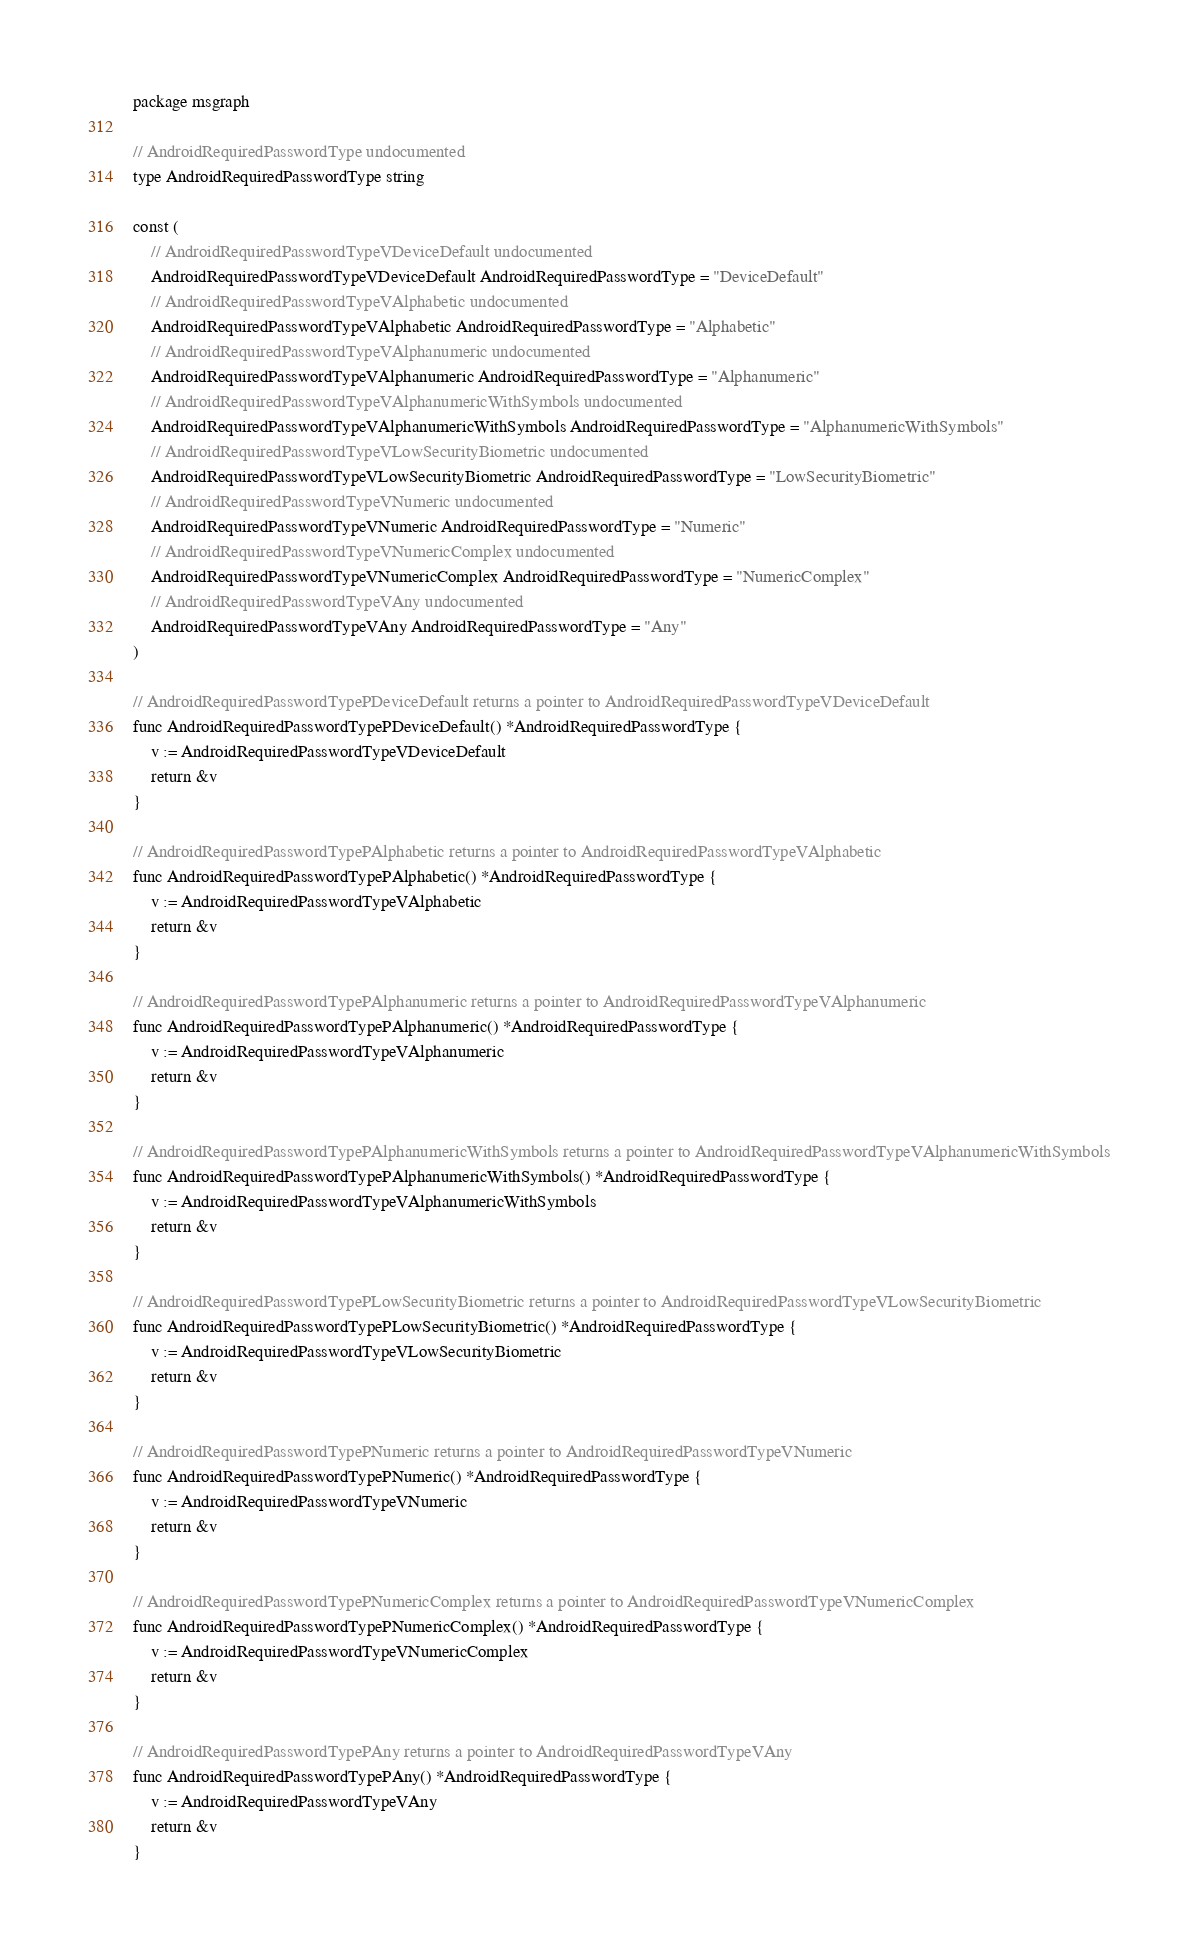Convert code to text. <code><loc_0><loc_0><loc_500><loc_500><_Go_>package msgraph

// AndroidRequiredPasswordType undocumented
type AndroidRequiredPasswordType string

const (
	// AndroidRequiredPasswordTypeVDeviceDefault undocumented
	AndroidRequiredPasswordTypeVDeviceDefault AndroidRequiredPasswordType = "DeviceDefault"
	// AndroidRequiredPasswordTypeVAlphabetic undocumented
	AndroidRequiredPasswordTypeVAlphabetic AndroidRequiredPasswordType = "Alphabetic"
	// AndroidRequiredPasswordTypeVAlphanumeric undocumented
	AndroidRequiredPasswordTypeVAlphanumeric AndroidRequiredPasswordType = "Alphanumeric"
	// AndroidRequiredPasswordTypeVAlphanumericWithSymbols undocumented
	AndroidRequiredPasswordTypeVAlphanumericWithSymbols AndroidRequiredPasswordType = "AlphanumericWithSymbols"
	// AndroidRequiredPasswordTypeVLowSecurityBiometric undocumented
	AndroidRequiredPasswordTypeVLowSecurityBiometric AndroidRequiredPasswordType = "LowSecurityBiometric"
	// AndroidRequiredPasswordTypeVNumeric undocumented
	AndroidRequiredPasswordTypeVNumeric AndroidRequiredPasswordType = "Numeric"
	// AndroidRequiredPasswordTypeVNumericComplex undocumented
	AndroidRequiredPasswordTypeVNumericComplex AndroidRequiredPasswordType = "NumericComplex"
	// AndroidRequiredPasswordTypeVAny undocumented
	AndroidRequiredPasswordTypeVAny AndroidRequiredPasswordType = "Any"
)

// AndroidRequiredPasswordTypePDeviceDefault returns a pointer to AndroidRequiredPasswordTypeVDeviceDefault
func AndroidRequiredPasswordTypePDeviceDefault() *AndroidRequiredPasswordType {
	v := AndroidRequiredPasswordTypeVDeviceDefault
	return &v
}

// AndroidRequiredPasswordTypePAlphabetic returns a pointer to AndroidRequiredPasswordTypeVAlphabetic
func AndroidRequiredPasswordTypePAlphabetic() *AndroidRequiredPasswordType {
	v := AndroidRequiredPasswordTypeVAlphabetic
	return &v
}

// AndroidRequiredPasswordTypePAlphanumeric returns a pointer to AndroidRequiredPasswordTypeVAlphanumeric
func AndroidRequiredPasswordTypePAlphanumeric() *AndroidRequiredPasswordType {
	v := AndroidRequiredPasswordTypeVAlphanumeric
	return &v
}

// AndroidRequiredPasswordTypePAlphanumericWithSymbols returns a pointer to AndroidRequiredPasswordTypeVAlphanumericWithSymbols
func AndroidRequiredPasswordTypePAlphanumericWithSymbols() *AndroidRequiredPasswordType {
	v := AndroidRequiredPasswordTypeVAlphanumericWithSymbols
	return &v
}

// AndroidRequiredPasswordTypePLowSecurityBiometric returns a pointer to AndroidRequiredPasswordTypeVLowSecurityBiometric
func AndroidRequiredPasswordTypePLowSecurityBiometric() *AndroidRequiredPasswordType {
	v := AndroidRequiredPasswordTypeVLowSecurityBiometric
	return &v
}

// AndroidRequiredPasswordTypePNumeric returns a pointer to AndroidRequiredPasswordTypeVNumeric
func AndroidRequiredPasswordTypePNumeric() *AndroidRequiredPasswordType {
	v := AndroidRequiredPasswordTypeVNumeric
	return &v
}

// AndroidRequiredPasswordTypePNumericComplex returns a pointer to AndroidRequiredPasswordTypeVNumericComplex
func AndroidRequiredPasswordTypePNumericComplex() *AndroidRequiredPasswordType {
	v := AndroidRequiredPasswordTypeVNumericComplex
	return &v
}

// AndroidRequiredPasswordTypePAny returns a pointer to AndroidRequiredPasswordTypeVAny
func AndroidRequiredPasswordTypePAny() *AndroidRequiredPasswordType {
	v := AndroidRequiredPasswordTypeVAny
	return &v
}
</code> 